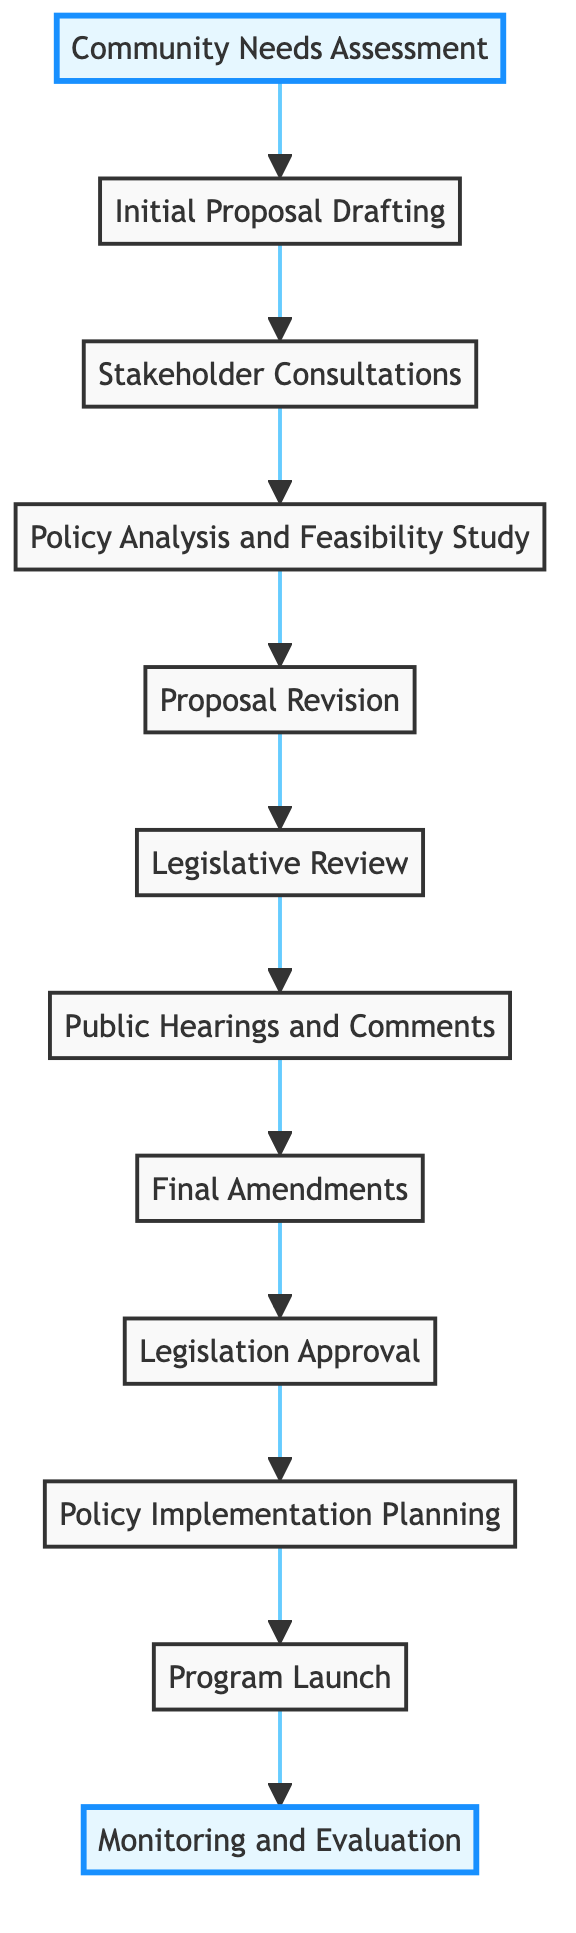What is the first step in the policy development process? The first step is "Community Needs Assessment," which is indicated as the bottom node in the flowchart.
Answer: Community Needs Assessment How many steps are in the policy development process? By counting the nodes in the diagram, there are 12 steps from the Community Needs Assessment to Monitoring and Evaluation.
Answer: 12 What comes immediately after Proposal Revision? The node that comes immediately after Proposal Revision is "Legislative Review," as indicated by the arrow pointing to it in the flowchart.
Answer: Legislative Review What type of feedback is collected during Public Hearings and Comments? During Public Hearings and Comments, feedback is collected from the general public and interest groups, as described in that node.
Answer: Public feedback Which step is focused on analyzing the proposed policy's feasibility? The step focused on feasibility is "Policy Analysis and Feasibility Study," which assesses feasibility, costs, and benefits.
Answer: Policy Analysis and Feasibility Study What is the final step of the policy development process? The final step in the flowchart is "Monitoring and Evaluation." This is indicated as the topmost node in the diagram.
Answer: Monitoring and Evaluation After legislation approval, what is the next step in the process? The next step after legislation approval is "Policy Implementation Planning," as shown in the flowchart following the Legislation Approval node.
Answer: Policy Implementation Planning Which two steps occur after Stakeholder Consultations? After Stakeholder Consultations, the two steps that follow are "Policy Analysis and Feasibility Study" and "Proposal Revision," indicating a sequence of analysis and revision.
Answer: Policy Analysis and Feasibility Study, Proposal Revision How does the diagram illustrate the flow of the policy development process? The flow is depicted by arrows pointing upward from one node to the next, indicating the progression from the first step at the bottom to the final step at the top.
Answer: Arrows pointing upward 